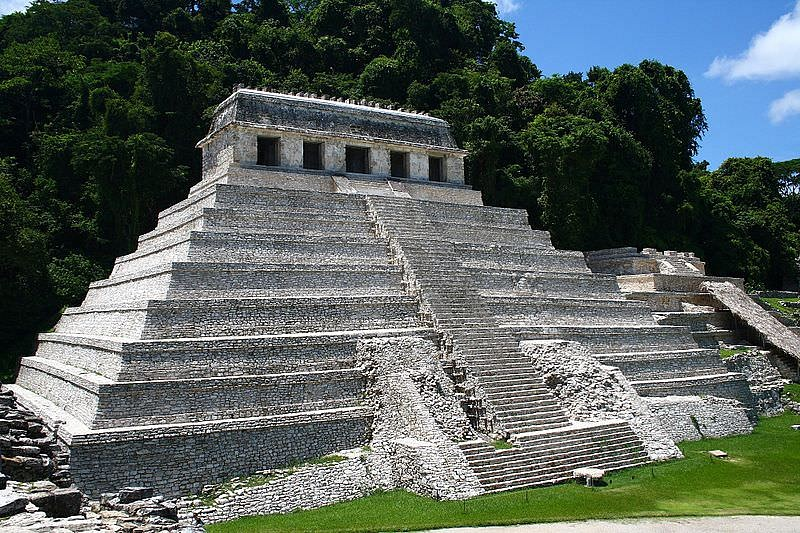Imagine the temple is a gateway to another world. What kind of world would it lead to? Imagine the Temple of the Inscriptions as a mystical gateway to another realm — a world brimming with wonder and mystery. Stepping through this ancient portal, one might enter a lush, verdant jungle teeming with extraordinary flora and fauna unlike anything on Earth. Giant, glowing trees would illuminate the surroundings with a soft, ethereal light, their leaves whispering ancient secrets in a language only the soul can understand. Hidden within this magical forest, crystal-clear rivers and waterfalls would sing harmoniously, resonating with the heartbeat of existence. The air would hum with the presence of unseen entities — guardians of an ancient wisdom, guiding you through trails lined with luminous stones that pulse with energy. In the heart of this enchanted world, a grand city of golden temples and floating gardens would stand as a testament to an advanced and enlightened civilization. Here, time flows differently, allowing visitors to explore and learn the profound truths that bind the cosmos together. It would be a world where the sacred and the mystical converge, offering an endless journey of discovery and transformation. 